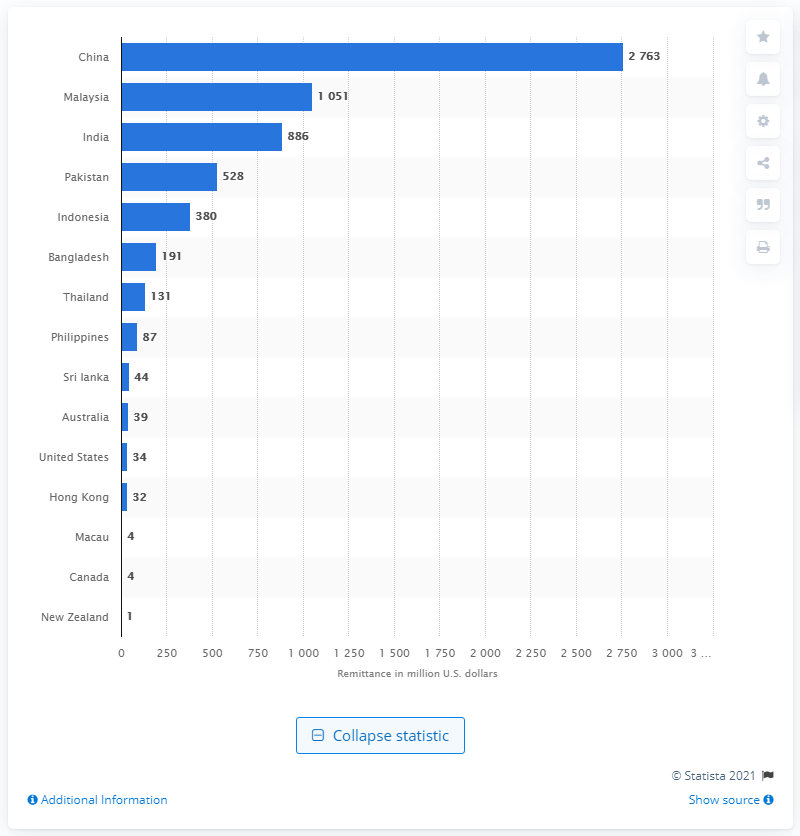Point out several critical features in this image. In 2017, the amount of dollars that people in Singapore transferred to China was 2763. 